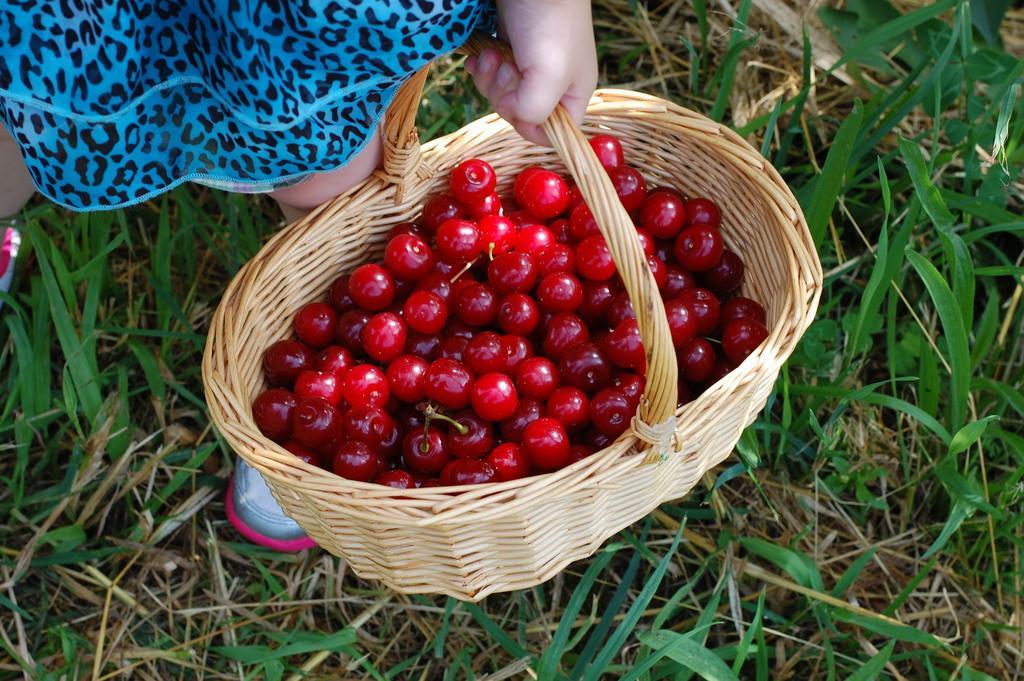Could you give a brief overview of what you see in this image? In this picture I can see a human holding a basket and I can see cherries in the basket and I can see grass on the ground. 